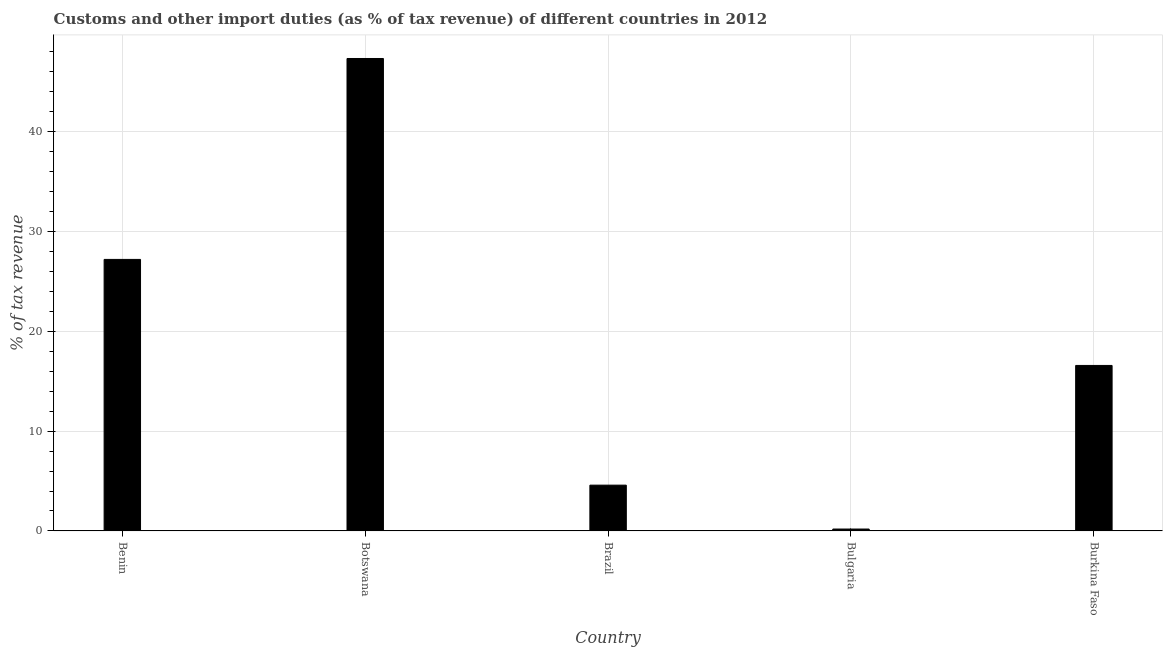Does the graph contain any zero values?
Offer a terse response. No. What is the title of the graph?
Ensure brevity in your answer.  Customs and other import duties (as % of tax revenue) of different countries in 2012. What is the label or title of the X-axis?
Your response must be concise. Country. What is the label or title of the Y-axis?
Your answer should be very brief. % of tax revenue. What is the customs and other import duties in Benin?
Give a very brief answer. 27.19. Across all countries, what is the maximum customs and other import duties?
Provide a succinct answer. 47.32. Across all countries, what is the minimum customs and other import duties?
Offer a very short reply. 0.19. In which country was the customs and other import duties maximum?
Your answer should be very brief. Botswana. In which country was the customs and other import duties minimum?
Your answer should be compact. Bulgaria. What is the sum of the customs and other import duties?
Offer a very short reply. 95.86. What is the difference between the customs and other import duties in Brazil and Bulgaria?
Offer a terse response. 4.4. What is the average customs and other import duties per country?
Your answer should be compact. 19.17. What is the median customs and other import duties?
Make the answer very short. 16.57. What is the ratio of the customs and other import duties in Bulgaria to that in Burkina Faso?
Provide a short and direct response. 0.01. Is the customs and other import duties in Benin less than that in Botswana?
Ensure brevity in your answer.  Yes. Is the difference between the customs and other import duties in Benin and Bulgaria greater than the difference between any two countries?
Ensure brevity in your answer.  No. What is the difference between the highest and the second highest customs and other import duties?
Your response must be concise. 20.12. Is the sum of the customs and other import duties in Brazil and Bulgaria greater than the maximum customs and other import duties across all countries?
Your answer should be compact. No. What is the difference between the highest and the lowest customs and other import duties?
Your response must be concise. 47.13. In how many countries, is the customs and other import duties greater than the average customs and other import duties taken over all countries?
Keep it short and to the point. 2. Are all the bars in the graph horizontal?
Give a very brief answer. No. How many countries are there in the graph?
Provide a short and direct response. 5. Are the values on the major ticks of Y-axis written in scientific E-notation?
Offer a very short reply. No. What is the % of tax revenue of Benin?
Offer a very short reply. 27.19. What is the % of tax revenue in Botswana?
Your answer should be very brief. 47.32. What is the % of tax revenue in Brazil?
Provide a succinct answer. 4.59. What is the % of tax revenue of Bulgaria?
Ensure brevity in your answer.  0.19. What is the % of tax revenue of Burkina Faso?
Your answer should be compact. 16.57. What is the difference between the % of tax revenue in Benin and Botswana?
Ensure brevity in your answer.  -20.12. What is the difference between the % of tax revenue in Benin and Brazil?
Give a very brief answer. 22.61. What is the difference between the % of tax revenue in Benin and Bulgaria?
Your answer should be compact. 27. What is the difference between the % of tax revenue in Benin and Burkina Faso?
Provide a succinct answer. 10.62. What is the difference between the % of tax revenue in Botswana and Brazil?
Offer a very short reply. 42.73. What is the difference between the % of tax revenue in Botswana and Bulgaria?
Offer a terse response. 47.13. What is the difference between the % of tax revenue in Botswana and Burkina Faso?
Provide a succinct answer. 30.74. What is the difference between the % of tax revenue in Brazil and Bulgaria?
Your answer should be very brief. 4.4. What is the difference between the % of tax revenue in Brazil and Burkina Faso?
Provide a short and direct response. -11.99. What is the difference between the % of tax revenue in Bulgaria and Burkina Faso?
Keep it short and to the point. -16.38. What is the ratio of the % of tax revenue in Benin to that in Botswana?
Offer a very short reply. 0.57. What is the ratio of the % of tax revenue in Benin to that in Brazil?
Ensure brevity in your answer.  5.93. What is the ratio of the % of tax revenue in Benin to that in Bulgaria?
Your answer should be compact. 142.64. What is the ratio of the % of tax revenue in Benin to that in Burkina Faso?
Your answer should be compact. 1.64. What is the ratio of the % of tax revenue in Botswana to that in Brazil?
Offer a very short reply. 10.32. What is the ratio of the % of tax revenue in Botswana to that in Bulgaria?
Make the answer very short. 248.19. What is the ratio of the % of tax revenue in Botswana to that in Burkina Faso?
Make the answer very short. 2.85. What is the ratio of the % of tax revenue in Brazil to that in Bulgaria?
Your answer should be compact. 24.06. What is the ratio of the % of tax revenue in Brazil to that in Burkina Faso?
Give a very brief answer. 0.28. What is the ratio of the % of tax revenue in Bulgaria to that in Burkina Faso?
Make the answer very short. 0.01. 